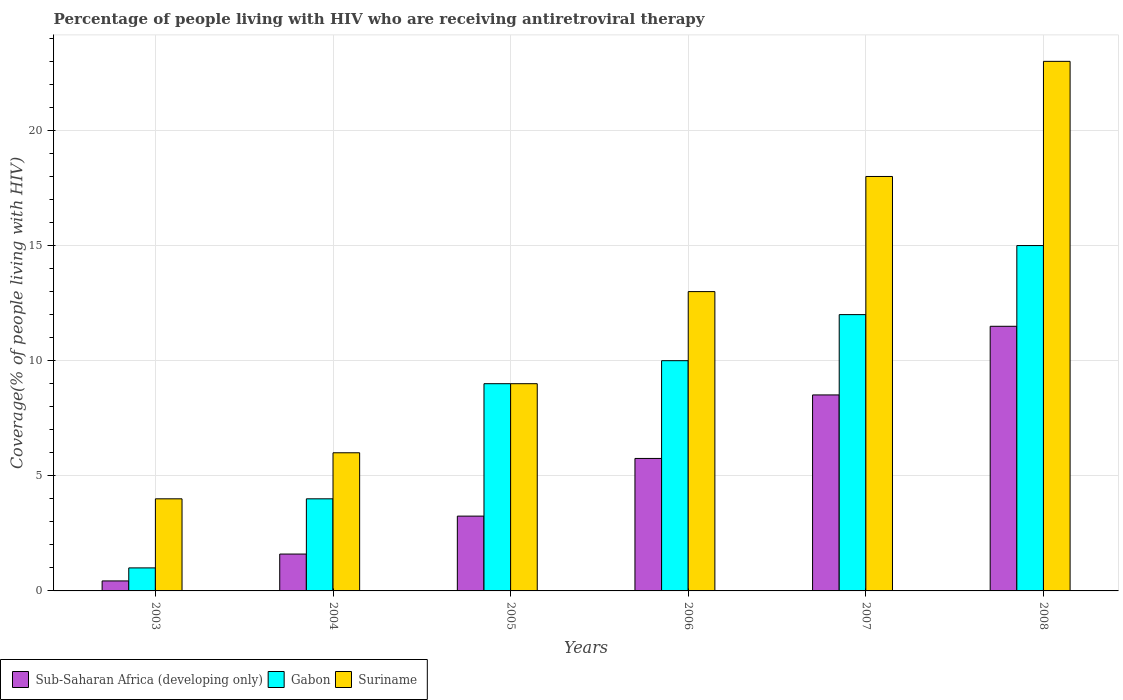How many groups of bars are there?
Keep it short and to the point. 6. Are the number of bars per tick equal to the number of legend labels?
Keep it short and to the point. Yes. How many bars are there on the 3rd tick from the left?
Provide a short and direct response. 3. What is the label of the 4th group of bars from the left?
Your answer should be compact. 2006. What is the percentage of the HIV infected people who are receiving antiretroviral therapy in Sub-Saharan Africa (developing only) in 2003?
Ensure brevity in your answer.  0.43. Across all years, what is the maximum percentage of the HIV infected people who are receiving antiretroviral therapy in Gabon?
Keep it short and to the point. 15. Across all years, what is the minimum percentage of the HIV infected people who are receiving antiretroviral therapy in Suriname?
Provide a succinct answer. 4. In which year was the percentage of the HIV infected people who are receiving antiretroviral therapy in Gabon minimum?
Ensure brevity in your answer.  2003. What is the total percentage of the HIV infected people who are receiving antiretroviral therapy in Gabon in the graph?
Your response must be concise. 51. What is the difference between the percentage of the HIV infected people who are receiving antiretroviral therapy in Sub-Saharan Africa (developing only) in 2005 and that in 2006?
Ensure brevity in your answer.  -2.5. What is the difference between the percentage of the HIV infected people who are receiving antiretroviral therapy in Suriname in 2007 and the percentage of the HIV infected people who are receiving antiretroviral therapy in Sub-Saharan Africa (developing only) in 2006?
Your answer should be very brief. 12.25. In the year 2007, what is the difference between the percentage of the HIV infected people who are receiving antiretroviral therapy in Gabon and percentage of the HIV infected people who are receiving antiretroviral therapy in Suriname?
Your answer should be compact. -6. In how many years, is the percentage of the HIV infected people who are receiving antiretroviral therapy in Suriname greater than 14 %?
Offer a terse response. 2. What is the ratio of the percentage of the HIV infected people who are receiving antiretroviral therapy in Suriname in 2004 to that in 2008?
Give a very brief answer. 0.26. Is the difference between the percentage of the HIV infected people who are receiving antiretroviral therapy in Gabon in 2003 and 2007 greater than the difference between the percentage of the HIV infected people who are receiving antiretroviral therapy in Suriname in 2003 and 2007?
Offer a very short reply. Yes. What is the difference between the highest and the second highest percentage of the HIV infected people who are receiving antiretroviral therapy in Suriname?
Offer a terse response. 5. What is the difference between the highest and the lowest percentage of the HIV infected people who are receiving antiretroviral therapy in Sub-Saharan Africa (developing only)?
Provide a short and direct response. 11.06. What does the 3rd bar from the left in 2003 represents?
Make the answer very short. Suriname. What does the 3rd bar from the right in 2008 represents?
Your answer should be very brief. Sub-Saharan Africa (developing only). How many years are there in the graph?
Provide a succinct answer. 6. Does the graph contain any zero values?
Offer a terse response. No. How many legend labels are there?
Your answer should be very brief. 3. What is the title of the graph?
Ensure brevity in your answer.  Percentage of people living with HIV who are receiving antiretroviral therapy. What is the label or title of the Y-axis?
Offer a terse response. Coverage(% of people living with HIV). What is the Coverage(% of people living with HIV) of Sub-Saharan Africa (developing only) in 2003?
Give a very brief answer. 0.43. What is the Coverage(% of people living with HIV) in Gabon in 2003?
Keep it short and to the point. 1. What is the Coverage(% of people living with HIV) of Suriname in 2003?
Make the answer very short. 4. What is the Coverage(% of people living with HIV) of Sub-Saharan Africa (developing only) in 2004?
Offer a terse response. 1.6. What is the Coverage(% of people living with HIV) in Gabon in 2004?
Ensure brevity in your answer.  4. What is the Coverage(% of people living with HIV) of Sub-Saharan Africa (developing only) in 2005?
Keep it short and to the point. 3.25. What is the Coverage(% of people living with HIV) of Sub-Saharan Africa (developing only) in 2006?
Make the answer very short. 5.75. What is the Coverage(% of people living with HIV) in Suriname in 2006?
Your answer should be compact. 13. What is the Coverage(% of people living with HIV) of Sub-Saharan Africa (developing only) in 2007?
Your answer should be very brief. 8.51. What is the Coverage(% of people living with HIV) of Suriname in 2007?
Give a very brief answer. 18. What is the Coverage(% of people living with HIV) in Sub-Saharan Africa (developing only) in 2008?
Keep it short and to the point. 11.49. What is the Coverage(% of people living with HIV) in Suriname in 2008?
Make the answer very short. 23. Across all years, what is the maximum Coverage(% of people living with HIV) in Sub-Saharan Africa (developing only)?
Your answer should be compact. 11.49. Across all years, what is the maximum Coverage(% of people living with HIV) of Gabon?
Your response must be concise. 15. Across all years, what is the minimum Coverage(% of people living with HIV) in Sub-Saharan Africa (developing only)?
Provide a short and direct response. 0.43. Across all years, what is the minimum Coverage(% of people living with HIV) in Gabon?
Offer a very short reply. 1. What is the total Coverage(% of people living with HIV) in Sub-Saharan Africa (developing only) in the graph?
Your response must be concise. 31.04. What is the total Coverage(% of people living with HIV) in Suriname in the graph?
Offer a terse response. 73. What is the difference between the Coverage(% of people living with HIV) of Sub-Saharan Africa (developing only) in 2003 and that in 2004?
Give a very brief answer. -1.17. What is the difference between the Coverage(% of people living with HIV) of Gabon in 2003 and that in 2004?
Offer a very short reply. -3. What is the difference between the Coverage(% of people living with HIV) in Suriname in 2003 and that in 2004?
Provide a succinct answer. -2. What is the difference between the Coverage(% of people living with HIV) of Sub-Saharan Africa (developing only) in 2003 and that in 2005?
Make the answer very short. -2.81. What is the difference between the Coverage(% of people living with HIV) in Suriname in 2003 and that in 2005?
Provide a succinct answer. -5. What is the difference between the Coverage(% of people living with HIV) in Sub-Saharan Africa (developing only) in 2003 and that in 2006?
Offer a terse response. -5.32. What is the difference between the Coverage(% of people living with HIV) in Suriname in 2003 and that in 2006?
Make the answer very short. -9. What is the difference between the Coverage(% of people living with HIV) of Sub-Saharan Africa (developing only) in 2003 and that in 2007?
Give a very brief answer. -8.08. What is the difference between the Coverage(% of people living with HIV) in Gabon in 2003 and that in 2007?
Offer a very short reply. -11. What is the difference between the Coverage(% of people living with HIV) of Suriname in 2003 and that in 2007?
Make the answer very short. -14. What is the difference between the Coverage(% of people living with HIV) in Sub-Saharan Africa (developing only) in 2003 and that in 2008?
Ensure brevity in your answer.  -11.06. What is the difference between the Coverage(% of people living with HIV) of Suriname in 2003 and that in 2008?
Provide a short and direct response. -19. What is the difference between the Coverage(% of people living with HIV) of Sub-Saharan Africa (developing only) in 2004 and that in 2005?
Provide a short and direct response. -1.65. What is the difference between the Coverage(% of people living with HIV) in Gabon in 2004 and that in 2005?
Your answer should be compact. -5. What is the difference between the Coverage(% of people living with HIV) of Sub-Saharan Africa (developing only) in 2004 and that in 2006?
Make the answer very short. -4.15. What is the difference between the Coverage(% of people living with HIV) in Suriname in 2004 and that in 2006?
Provide a short and direct response. -7. What is the difference between the Coverage(% of people living with HIV) of Sub-Saharan Africa (developing only) in 2004 and that in 2007?
Your answer should be compact. -6.91. What is the difference between the Coverage(% of people living with HIV) of Gabon in 2004 and that in 2007?
Offer a very short reply. -8. What is the difference between the Coverage(% of people living with HIV) of Suriname in 2004 and that in 2007?
Ensure brevity in your answer.  -12. What is the difference between the Coverage(% of people living with HIV) in Sub-Saharan Africa (developing only) in 2004 and that in 2008?
Ensure brevity in your answer.  -9.89. What is the difference between the Coverage(% of people living with HIV) in Suriname in 2004 and that in 2008?
Your answer should be very brief. -17. What is the difference between the Coverage(% of people living with HIV) in Sub-Saharan Africa (developing only) in 2005 and that in 2006?
Ensure brevity in your answer.  -2.5. What is the difference between the Coverage(% of people living with HIV) in Sub-Saharan Africa (developing only) in 2005 and that in 2007?
Your response must be concise. -5.26. What is the difference between the Coverage(% of people living with HIV) in Gabon in 2005 and that in 2007?
Provide a succinct answer. -3. What is the difference between the Coverage(% of people living with HIV) in Sub-Saharan Africa (developing only) in 2005 and that in 2008?
Your response must be concise. -8.24. What is the difference between the Coverage(% of people living with HIV) of Suriname in 2005 and that in 2008?
Give a very brief answer. -14. What is the difference between the Coverage(% of people living with HIV) of Sub-Saharan Africa (developing only) in 2006 and that in 2007?
Provide a short and direct response. -2.76. What is the difference between the Coverage(% of people living with HIV) of Sub-Saharan Africa (developing only) in 2006 and that in 2008?
Your answer should be compact. -5.74. What is the difference between the Coverage(% of people living with HIV) of Gabon in 2006 and that in 2008?
Provide a succinct answer. -5. What is the difference between the Coverage(% of people living with HIV) of Sub-Saharan Africa (developing only) in 2007 and that in 2008?
Provide a succinct answer. -2.98. What is the difference between the Coverage(% of people living with HIV) of Suriname in 2007 and that in 2008?
Keep it short and to the point. -5. What is the difference between the Coverage(% of people living with HIV) of Sub-Saharan Africa (developing only) in 2003 and the Coverage(% of people living with HIV) of Gabon in 2004?
Provide a short and direct response. -3.57. What is the difference between the Coverage(% of people living with HIV) of Sub-Saharan Africa (developing only) in 2003 and the Coverage(% of people living with HIV) of Suriname in 2004?
Keep it short and to the point. -5.57. What is the difference between the Coverage(% of people living with HIV) of Sub-Saharan Africa (developing only) in 2003 and the Coverage(% of people living with HIV) of Gabon in 2005?
Give a very brief answer. -8.57. What is the difference between the Coverage(% of people living with HIV) of Sub-Saharan Africa (developing only) in 2003 and the Coverage(% of people living with HIV) of Suriname in 2005?
Your answer should be very brief. -8.57. What is the difference between the Coverage(% of people living with HIV) of Gabon in 2003 and the Coverage(% of people living with HIV) of Suriname in 2005?
Provide a succinct answer. -8. What is the difference between the Coverage(% of people living with HIV) of Sub-Saharan Africa (developing only) in 2003 and the Coverage(% of people living with HIV) of Gabon in 2006?
Offer a very short reply. -9.57. What is the difference between the Coverage(% of people living with HIV) of Sub-Saharan Africa (developing only) in 2003 and the Coverage(% of people living with HIV) of Suriname in 2006?
Provide a succinct answer. -12.57. What is the difference between the Coverage(% of people living with HIV) of Gabon in 2003 and the Coverage(% of people living with HIV) of Suriname in 2006?
Offer a terse response. -12. What is the difference between the Coverage(% of people living with HIV) of Sub-Saharan Africa (developing only) in 2003 and the Coverage(% of people living with HIV) of Gabon in 2007?
Provide a short and direct response. -11.57. What is the difference between the Coverage(% of people living with HIV) of Sub-Saharan Africa (developing only) in 2003 and the Coverage(% of people living with HIV) of Suriname in 2007?
Your answer should be very brief. -17.57. What is the difference between the Coverage(% of people living with HIV) of Gabon in 2003 and the Coverage(% of people living with HIV) of Suriname in 2007?
Ensure brevity in your answer.  -17. What is the difference between the Coverage(% of people living with HIV) in Sub-Saharan Africa (developing only) in 2003 and the Coverage(% of people living with HIV) in Gabon in 2008?
Provide a short and direct response. -14.57. What is the difference between the Coverage(% of people living with HIV) of Sub-Saharan Africa (developing only) in 2003 and the Coverage(% of people living with HIV) of Suriname in 2008?
Your answer should be compact. -22.57. What is the difference between the Coverage(% of people living with HIV) of Sub-Saharan Africa (developing only) in 2004 and the Coverage(% of people living with HIV) of Gabon in 2005?
Your answer should be very brief. -7.4. What is the difference between the Coverage(% of people living with HIV) in Sub-Saharan Africa (developing only) in 2004 and the Coverage(% of people living with HIV) in Suriname in 2005?
Provide a short and direct response. -7.4. What is the difference between the Coverage(% of people living with HIV) in Gabon in 2004 and the Coverage(% of people living with HIV) in Suriname in 2005?
Ensure brevity in your answer.  -5. What is the difference between the Coverage(% of people living with HIV) of Sub-Saharan Africa (developing only) in 2004 and the Coverage(% of people living with HIV) of Gabon in 2006?
Give a very brief answer. -8.4. What is the difference between the Coverage(% of people living with HIV) of Sub-Saharan Africa (developing only) in 2004 and the Coverage(% of people living with HIV) of Suriname in 2006?
Your response must be concise. -11.4. What is the difference between the Coverage(% of people living with HIV) in Sub-Saharan Africa (developing only) in 2004 and the Coverage(% of people living with HIV) in Gabon in 2007?
Ensure brevity in your answer.  -10.4. What is the difference between the Coverage(% of people living with HIV) in Sub-Saharan Africa (developing only) in 2004 and the Coverage(% of people living with HIV) in Suriname in 2007?
Your response must be concise. -16.4. What is the difference between the Coverage(% of people living with HIV) of Gabon in 2004 and the Coverage(% of people living with HIV) of Suriname in 2007?
Your answer should be very brief. -14. What is the difference between the Coverage(% of people living with HIV) of Sub-Saharan Africa (developing only) in 2004 and the Coverage(% of people living with HIV) of Gabon in 2008?
Offer a terse response. -13.4. What is the difference between the Coverage(% of people living with HIV) of Sub-Saharan Africa (developing only) in 2004 and the Coverage(% of people living with HIV) of Suriname in 2008?
Provide a short and direct response. -21.4. What is the difference between the Coverage(% of people living with HIV) in Sub-Saharan Africa (developing only) in 2005 and the Coverage(% of people living with HIV) in Gabon in 2006?
Keep it short and to the point. -6.75. What is the difference between the Coverage(% of people living with HIV) in Sub-Saharan Africa (developing only) in 2005 and the Coverage(% of people living with HIV) in Suriname in 2006?
Give a very brief answer. -9.75. What is the difference between the Coverage(% of people living with HIV) in Gabon in 2005 and the Coverage(% of people living with HIV) in Suriname in 2006?
Offer a terse response. -4. What is the difference between the Coverage(% of people living with HIV) in Sub-Saharan Africa (developing only) in 2005 and the Coverage(% of people living with HIV) in Gabon in 2007?
Keep it short and to the point. -8.75. What is the difference between the Coverage(% of people living with HIV) in Sub-Saharan Africa (developing only) in 2005 and the Coverage(% of people living with HIV) in Suriname in 2007?
Offer a very short reply. -14.75. What is the difference between the Coverage(% of people living with HIV) in Gabon in 2005 and the Coverage(% of people living with HIV) in Suriname in 2007?
Your answer should be compact. -9. What is the difference between the Coverage(% of people living with HIV) of Sub-Saharan Africa (developing only) in 2005 and the Coverage(% of people living with HIV) of Gabon in 2008?
Offer a terse response. -11.75. What is the difference between the Coverage(% of people living with HIV) of Sub-Saharan Africa (developing only) in 2005 and the Coverage(% of people living with HIV) of Suriname in 2008?
Your answer should be very brief. -19.75. What is the difference between the Coverage(% of people living with HIV) of Gabon in 2005 and the Coverage(% of people living with HIV) of Suriname in 2008?
Make the answer very short. -14. What is the difference between the Coverage(% of people living with HIV) of Sub-Saharan Africa (developing only) in 2006 and the Coverage(% of people living with HIV) of Gabon in 2007?
Provide a succinct answer. -6.25. What is the difference between the Coverage(% of people living with HIV) in Sub-Saharan Africa (developing only) in 2006 and the Coverage(% of people living with HIV) in Suriname in 2007?
Give a very brief answer. -12.25. What is the difference between the Coverage(% of people living with HIV) of Gabon in 2006 and the Coverage(% of people living with HIV) of Suriname in 2007?
Provide a succinct answer. -8. What is the difference between the Coverage(% of people living with HIV) in Sub-Saharan Africa (developing only) in 2006 and the Coverage(% of people living with HIV) in Gabon in 2008?
Ensure brevity in your answer.  -9.25. What is the difference between the Coverage(% of people living with HIV) of Sub-Saharan Africa (developing only) in 2006 and the Coverage(% of people living with HIV) of Suriname in 2008?
Offer a terse response. -17.25. What is the difference between the Coverage(% of people living with HIV) in Gabon in 2006 and the Coverage(% of people living with HIV) in Suriname in 2008?
Give a very brief answer. -13. What is the difference between the Coverage(% of people living with HIV) of Sub-Saharan Africa (developing only) in 2007 and the Coverage(% of people living with HIV) of Gabon in 2008?
Keep it short and to the point. -6.49. What is the difference between the Coverage(% of people living with HIV) in Sub-Saharan Africa (developing only) in 2007 and the Coverage(% of people living with HIV) in Suriname in 2008?
Provide a short and direct response. -14.49. What is the difference between the Coverage(% of people living with HIV) of Gabon in 2007 and the Coverage(% of people living with HIV) of Suriname in 2008?
Keep it short and to the point. -11. What is the average Coverage(% of people living with HIV) in Sub-Saharan Africa (developing only) per year?
Your response must be concise. 5.17. What is the average Coverage(% of people living with HIV) in Suriname per year?
Your answer should be very brief. 12.17. In the year 2003, what is the difference between the Coverage(% of people living with HIV) in Sub-Saharan Africa (developing only) and Coverage(% of people living with HIV) in Gabon?
Your answer should be compact. -0.57. In the year 2003, what is the difference between the Coverage(% of people living with HIV) of Sub-Saharan Africa (developing only) and Coverage(% of people living with HIV) of Suriname?
Offer a terse response. -3.57. In the year 2003, what is the difference between the Coverage(% of people living with HIV) of Gabon and Coverage(% of people living with HIV) of Suriname?
Make the answer very short. -3. In the year 2004, what is the difference between the Coverage(% of people living with HIV) of Sub-Saharan Africa (developing only) and Coverage(% of people living with HIV) of Gabon?
Offer a very short reply. -2.4. In the year 2004, what is the difference between the Coverage(% of people living with HIV) in Sub-Saharan Africa (developing only) and Coverage(% of people living with HIV) in Suriname?
Your answer should be compact. -4.4. In the year 2004, what is the difference between the Coverage(% of people living with HIV) of Gabon and Coverage(% of people living with HIV) of Suriname?
Ensure brevity in your answer.  -2. In the year 2005, what is the difference between the Coverage(% of people living with HIV) in Sub-Saharan Africa (developing only) and Coverage(% of people living with HIV) in Gabon?
Ensure brevity in your answer.  -5.75. In the year 2005, what is the difference between the Coverage(% of people living with HIV) of Sub-Saharan Africa (developing only) and Coverage(% of people living with HIV) of Suriname?
Ensure brevity in your answer.  -5.75. In the year 2005, what is the difference between the Coverage(% of people living with HIV) of Gabon and Coverage(% of people living with HIV) of Suriname?
Give a very brief answer. 0. In the year 2006, what is the difference between the Coverage(% of people living with HIV) in Sub-Saharan Africa (developing only) and Coverage(% of people living with HIV) in Gabon?
Give a very brief answer. -4.25. In the year 2006, what is the difference between the Coverage(% of people living with HIV) in Sub-Saharan Africa (developing only) and Coverage(% of people living with HIV) in Suriname?
Your answer should be compact. -7.25. In the year 2007, what is the difference between the Coverage(% of people living with HIV) of Sub-Saharan Africa (developing only) and Coverage(% of people living with HIV) of Gabon?
Offer a very short reply. -3.49. In the year 2007, what is the difference between the Coverage(% of people living with HIV) of Sub-Saharan Africa (developing only) and Coverage(% of people living with HIV) of Suriname?
Offer a terse response. -9.49. In the year 2008, what is the difference between the Coverage(% of people living with HIV) of Sub-Saharan Africa (developing only) and Coverage(% of people living with HIV) of Gabon?
Give a very brief answer. -3.51. In the year 2008, what is the difference between the Coverage(% of people living with HIV) in Sub-Saharan Africa (developing only) and Coverage(% of people living with HIV) in Suriname?
Your answer should be very brief. -11.51. In the year 2008, what is the difference between the Coverage(% of people living with HIV) in Gabon and Coverage(% of people living with HIV) in Suriname?
Your response must be concise. -8. What is the ratio of the Coverage(% of people living with HIV) of Sub-Saharan Africa (developing only) in 2003 to that in 2004?
Keep it short and to the point. 0.27. What is the ratio of the Coverage(% of people living with HIV) in Gabon in 2003 to that in 2004?
Provide a succinct answer. 0.25. What is the ratio of the Coverage(% of people living with HIV) of Suriname in 2003 to that in 2004?
Ensure brevity in your answer.  0.67. What is the ratio of the Coverage(% of people living with HIV) of Sub-Saharan Africa (developing only) in 2003 to that in 2005?
Give a very brief answer. 0.13. What is the ratio of the Coverage(% of people living with HIV) in Gabon in 2003 to that in 2005?
Give a very brief answer. 0.11. What is the ratio of the Coverage(% of people living with HIV) in Suriname in 2003 to that in 2005?
Provide a short and direct response. 0.44. What is the ratio of the Coverage(% of people living with HIV) in Sub-Saharan Africa (developing only) in 2003 to that in 2006?
Your answer should be compact. 0.08. What is the ratio of the Coverage(% of people living with HIV) of Gabon in 2003 to that in 2006?
Offer a terse response. 0.1. What is the ratio of the Coverage(% of people living with HIV) of Suriname in 2003 to that in 2006?
Ensure brevity in your answer.  0.31. What is the ratio of the Coverage(% of people living with HIV) of Sub-Saharan Africa (developing only) in 2003 to that in 2007?
Ensure brevity in your answer.  0.05. What is the ratio of the Coverage(% of people living with HIV) in Gabon in 2003 to that in 2007?
Offer a very short reply. 0.08. What is the ratio of the Coverage(% of people living with HIV) of Suriname in 2003 to that in 2007?
Give a very brief answer. 0.22. What is the ratio of the Coverage(% of people living with HIV) of Sub-Saharan Africa (developing only) in 2003 to that in 2008?
Give a very brief answer. 0.04. What is the ratio of the Coverage(% of people living with HIV) of Gabon in 2003 to that in 2008?
Offer a terse response. 0.07. What is the ratio of the Coverage(% of people living with HIV) of Suriname in 2003 to that in 2008?
Provide a short and direct response. 0.17. What is the ratio of the Coverage(% of people living with HIV) in Sub-Saharan Africa (developing only) in 2004 to that in 2005?
Your answer should be very brief. 0.49. What is the ratio of the Coverage(% of people living with HIV) in Gabon in 2004 to that in 2005?
Ensure brevity in your answer.  0.44. What is the ratio of the Coverage(% of people living with HIV) of Suriname in 2004 to that in 2005?
Make the answer very short. 0.67. What is the ratio of the Coverage(% of people living with HIV) in Sub-Saharan Africa (developing only) in 2004 to that in 2006?
Provide a short and direct response. 0.28. What is the ratio of the Coverage(% of people living with HIV) of Gabon in 2004 to that in 2006?
Ensure brevity in your answer.  0.4. What is the ratio of the Coverage(% of people living with HIV) in Suriname in 2004 to that in 2006?
Provide a short and direct response. 0.46. What is the ratio of the Coverage(% of people living with HIV) of Sub-Saharan Africa (developing only) in 2004 to that in 2007?
Your response must be concise. 0.19. What is the ratio of the Coverage(% of people living with HIV) in Gabon in 2004 to that in 2007?
Offer a very short reply. 0.33. What is the ratio of the Coverage(% of people living with HIV) in Suriname in 2004 to that in 2007?
Offer a very short reply. 0.33. What is the ratio of the Coverage(% of people living with HIV) of Sub-Saharan Africa (developing only) in 2004 to that in 2008?
Give a very brief answer. 0.14. What is the ratio of the Coverage(% of people living with HIV) in Gabon in 2004 to that in 2008?
Provide a short and direct response. 0.27. What is the ratio of the Coverage(% of people living with HIV) of Suriname in 2004 to that in 2008?
Provide a short and direct response. 0.26. What is the ratio of the Coverage(% of people living with HIV) in Sub-Saharan Africa (developing only) in 2005 to that in 2006?
Provide a short and direct response. 0.56. What is the ratio of the Coverage(% of people living with HIV) in Gabon in 2005 to that in 2006?
Provide a short and direct response. 0.9. What is the ratio of the Coverage(% of people living with HIV) in Suriname in 2005 to that in 2006?
Ensure brevity in your answer.  0.69. What is the ratio of the Coverage(% of people living with HIV) of Sub-Saharan Africa (developing only) in 2005 to that in 2007?
Offer a very short reply. 0.38. What is the ratio of the Coverage(% of people living with HIV) in Suriname in 2005 to that in 2007?
Your response must be concise. 0.5. What is the ratio of the Coverage(% of people living with HIV) in Sub-Saharan Africa (developing only) in 2005 to that in 2008?
Offer a very short reply. 0.28. What is the ratio of the Coverage(% of people living with HIV) in Suriname in 2005 to that in 2008?
Make the answer very short. 0.39. What is the ratio of the Coverage(% of people living with HIV) of Sub-Saharan Africa (developing only) in 2006 to that in 2007?
Keep it short and to the point. 0.68. What is the ratio of the Coverage(% of people living with HIV) of Suriname in 2006 to that in 2007?
Make the answer very short. 0.72. What is the ratio of the Coverage(% of people living with HIV) in Sub-Saharan Africa (developing only) in 2006 to that in 2008?
Your answer should be very brief. 0.5. What is the ratio of the Coverage(% of people living with HIV) of Suriname in 2006 to that in 2008?
Keep it short and to the point. 0.57. What is the ratio of the Coverage(% of people living with HIV) in Sub-Saharan Africa (developing only) in 2007 to that in 2008?
Ensure brevity in your answer.  0.74. What is the ratio of the Coverage(% of people living with HIV) of Gabon in 2007 to that in 2008?
Offer a very short reply. 0.8. What is the ratio of the Coverage(% of people living with HIV) of Suriname in 2007 to that in 2008?
Keep it short and to the point. 0.78. What is the difference between the highest and the second highest Coverage(% of people living with HIV) in Sub-Saharan Africa (developing only)?
Ensure brevity in your answer.  2.98. What is the difference between the highest and the second highest Coverage(% of people living with HIV) in Gabon?
Provide a short and direct response. 3. What is the difference between the highest and the second highest Coverage(% of people living with HIV) in Suriname?
Offer a terse response. 5. What is the difference between the highest and the lowest Coverage(% of people living with HIV) of Sub-Saharan Africa (developing only)?
Keep it short and to the point. 11.06. What is the difference between the highest and the lowest Coverage(% of people living with HIV) of Gabon?
Make the answer very short. 14. What is the difference between the highest and the lowest Coverage(% of people living with HIV) of Suriname?
Keep it short and to the point. 19. 